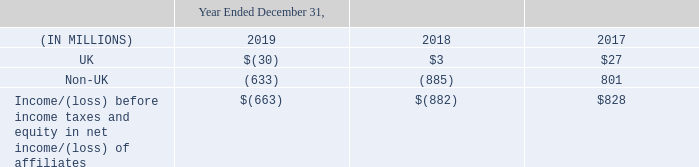15. Income Taxes
Nielsen provides for income taxes utilizing the asset and liability method of accounting for income taxes. Under this method, deferred income taxes are recorded to reflect the tax consequences in future years of differences between the tax basis of assets and liabilities and their financial reporting amounts at each balance sheet date, based on enacted tax laws and statutory tax rates applicable to the periods in which the differences are expected to affect taxable income. If it is determined that it is more likely than not that future tax benefits associated with a deferred tax asset will not be realized, a valuation allowance is provided. The effect on deferred tax assets and liabilities of a change in the tax rates is recognized in the consolidated statements of operations as an adjustment to income tax expense in the period that includes the enactment date.
The Company records a liability for unrecognized tax benefits resulting from uncertain tax positions taken or expected to be taken in a tax return. Such tax positions are, based solely on their technical merits, more likely than not to be sustained upon examination by taxing authorities and reflect the largest amount of benefit, determined on a cumulative probability basis that is more likely than not to be realized upon settlement with the applicable taxing authority with full knowledge of all relevant information. The Company recognizes interest and penalties, if any, related to unrecognized tax benefits in income tax expense.
On December 22, 2017, the TCJA was signed into law and significantly changed the way the U.S. taxes corporations. The TCJA reduced the U.S. federal corporate income tax rate from 35 percent to 21 percent and created a territorial-style taxing system. The TCJA required companies to pay a one-time transition tax on earnings of certain foreign subsidiaries that were previously deferred and also created new taxes on certain types of foreign earnings. As of December 31, 2017, we made a reasonable estimate of the (a) effects on our existing deferred tax balances, and (b) the one-time transition tax. Consequently, our fourth quarter of 2017 and full year 2017 results of operations reflected a non-cash provisional net expense of $104 million. We finalized our accounting for the TCJA in December of 2018 and our results for the fourth quarter of 2018 and full year 2018 results of operations reflect, in accordance with SAB 118, a reduction in tax expense of $252 million as an adjustment to the 2017 provisional expense. This was primarily comprised of a net tax benefit of $57 million relating to finalizing the calculation of the transition tax (including withholding taxes) together with a net tax benefit of $195 million associated with the re-measurement of our deferred taxes.
The TCJA imposed a U.S. tax on global intangible low taxed income (“GILTI”) that is earned by certain foreign affiliates owned by a U.S. shareholder and was intended to tax earnings of a foreign corporation that are deemed to be in excess of certain threshold return. As of December 31, 2018, Nielsen made a policy decision and elected to treat taxes on GILTI as a current period expense and have reflected as such within the financial statements as of December 31, 2019 as well.
As part of an intercompany restructuring during the year ended December 31, 2018, we transferred certain intellectual property assets between wholly- owned legal entities in non-U.S. tax jurisdictions. As the impact of the transfer was the result of an intra-entity transaction, the resulting gain on the transfer was eliminated for purposes of the consolidated financial statements. The transferring entity recognized a gain on the transfer of assets that was not subject to income tax in its local jurisdiction. In accordance with ASU 2016-16, which the Company adopted in the first quarter of 2018, and as further described in Note 1. “Significant Accounting Policies”, Nielsen recorded an income tax benefit of approximately $193 million.
Throughout 2019, ongoing federal and international audits were effectively settled in certain tax jurisdictions and the impact was recorded accordingly the financial statements.
The components of income/(loss) before income taxes and equity in net income of affiliates, were:
The above amounts for UK and non-UK activities were determined based on the location of the taxing authorities.
What was the income tax benefit recorded by Nielsen when the Company adopted ASU 2016-16? $193 million. What is the amount of UK income loss before income taxes and equity in net income of affiliates for the year ended December 31, 2019?
Answer scale should be: million. 30. What is the amount of non-UK  income loss before income taxes and equity in net income of affiliates for the year ended December 31, 2018?
Answer scale should be: million. 885. What is the percentage change in the loss before income taxes and equity in net income/(loss) of affiliates from 2018 to 2019?
Answer scale should be: percent. (663-882)/882
Answer: -24.83. What is the percentage of non-UK activities in loss before income taxes and equity in net loss of affiliates for the year ended December 31, 2019?
Answer scale should be: percent. 633/663
Answer: 95.48. What is the percentage change in the UK activities from 2018 to 2019?
Answer scale should be: percent. (-30-3)/3
Answer: -11. 